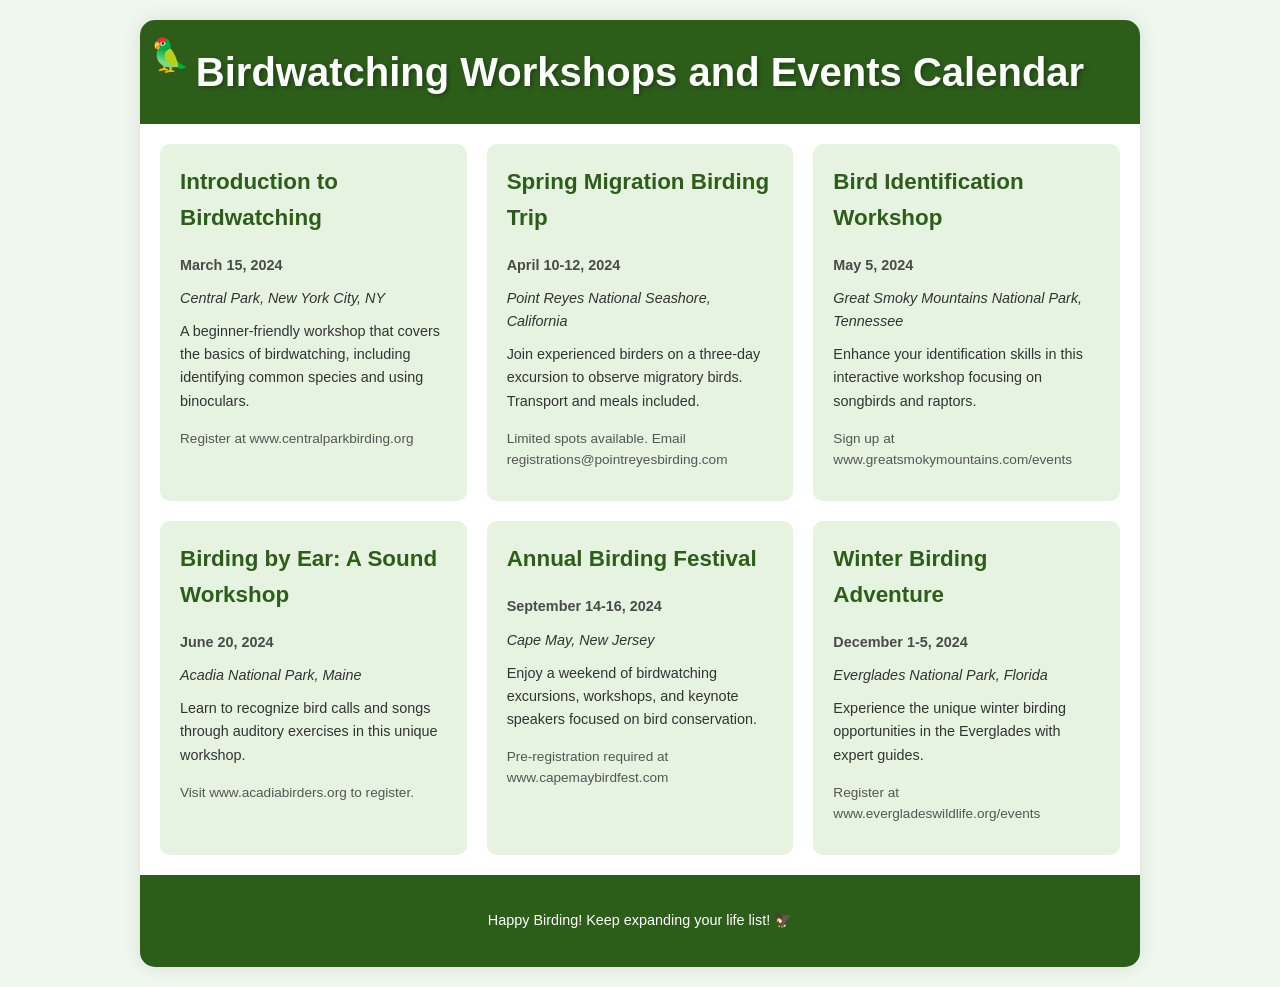What is the date of the Introduction to Birdwatching workshop? The date is mentioned in the event details under the "date" section for the workshop.
Answer: March 15, 2024 Where is the Spring Migration Birding Trip located? The location can be found in the "location" section of the event description for the Spring Migration Birding Trip.
Answer: Point Reyes National Seashore, California What is the main focus of the Bird Identification Workshop? The focus of the workshop is described in the event's details and specifies the types of birds covered.
Answer: Songbirds and raptors How many days does the Winter Birding Adventure span? The duration is indicated in the "date" section for the Winter Birding Adventure event.
Answer: Five days What is required for the Annual Birding Festival registration? The registration details indicate what is needed for securing a spot at the festival.
Answer: Pre-registration Which workshop focuses specifically on bird calls? This information can be found in the title and description of the relevant workshop.
Answer: Birding by Ear: A Sound Workshop When does the Birding by Ear workshop take place? The date is stated in the "date" section for the Birding by Ear workshop.
Answer: June 20, 2024 What type of event is the Annual Birding Festival considered? The event type can be inferred from the description of activities highlighted in the festival details.
Answer: A weekend of birdwatching excursions and workshops How can I register for the Great Smoky Mountains workshop? The registration method is explicitly mentioned in the details section for the workshop.
Answer: Sign up at www.greatsmokymountains.com/events 